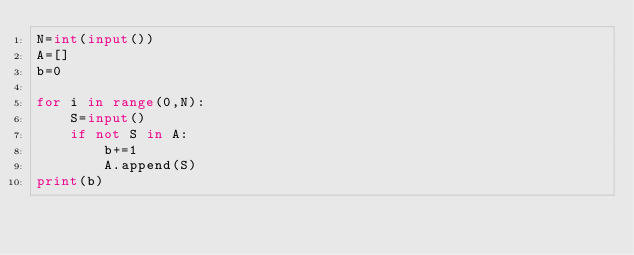<code> <loc_0><loc_0><loc_500><loc_500><_Python_>N=int(input())
A=[]
b=0

for i in range(0,N):
    S=input()
    if not S in A:
        b+=1
        A.append(S)
print(b)</code> 